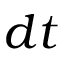Convert formula to latex. <formula><loc_0><loc_0><loc_500><loc_500>d t</formula> 